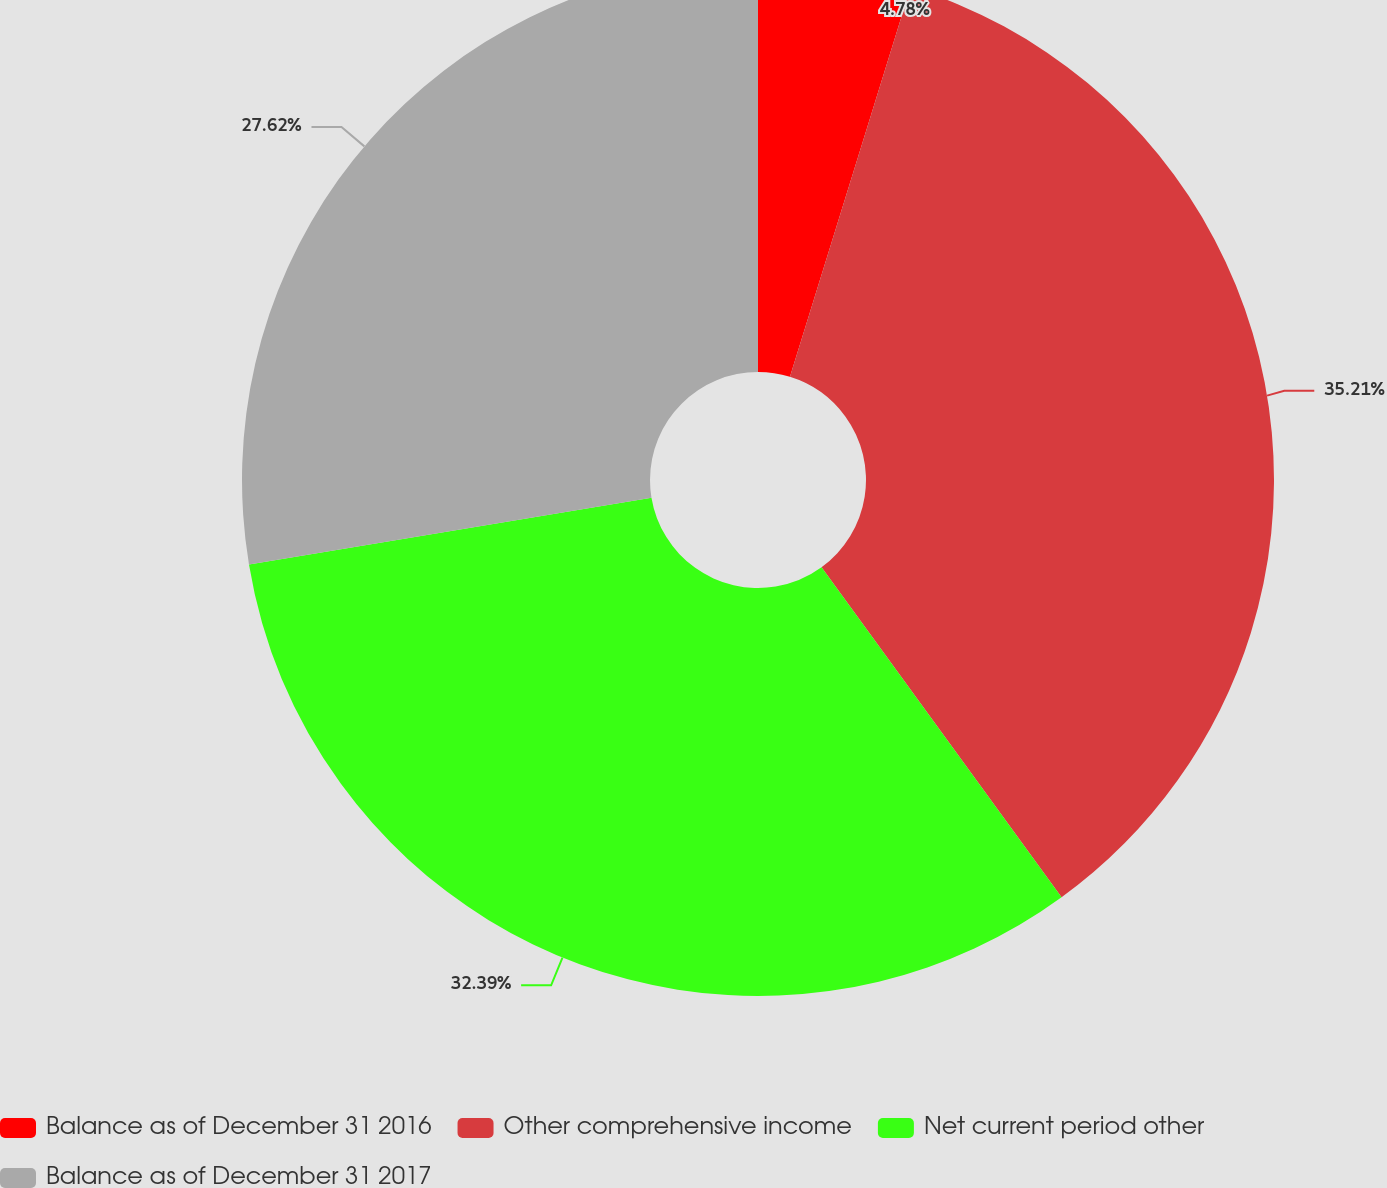Convert chart to OTSL. <chart><loc_0><loc_0><loc_500><loc_500><pie_chart><fcel>Balance as of December 31 2016<fcel>Other comprehensive income<fcel>Net current period other<fcel>Balance as of December 31 2017<nl><fcel>4.78%<fcel>35.21%<fcel>32.39%<fcel>27.62%<nl></chart> 